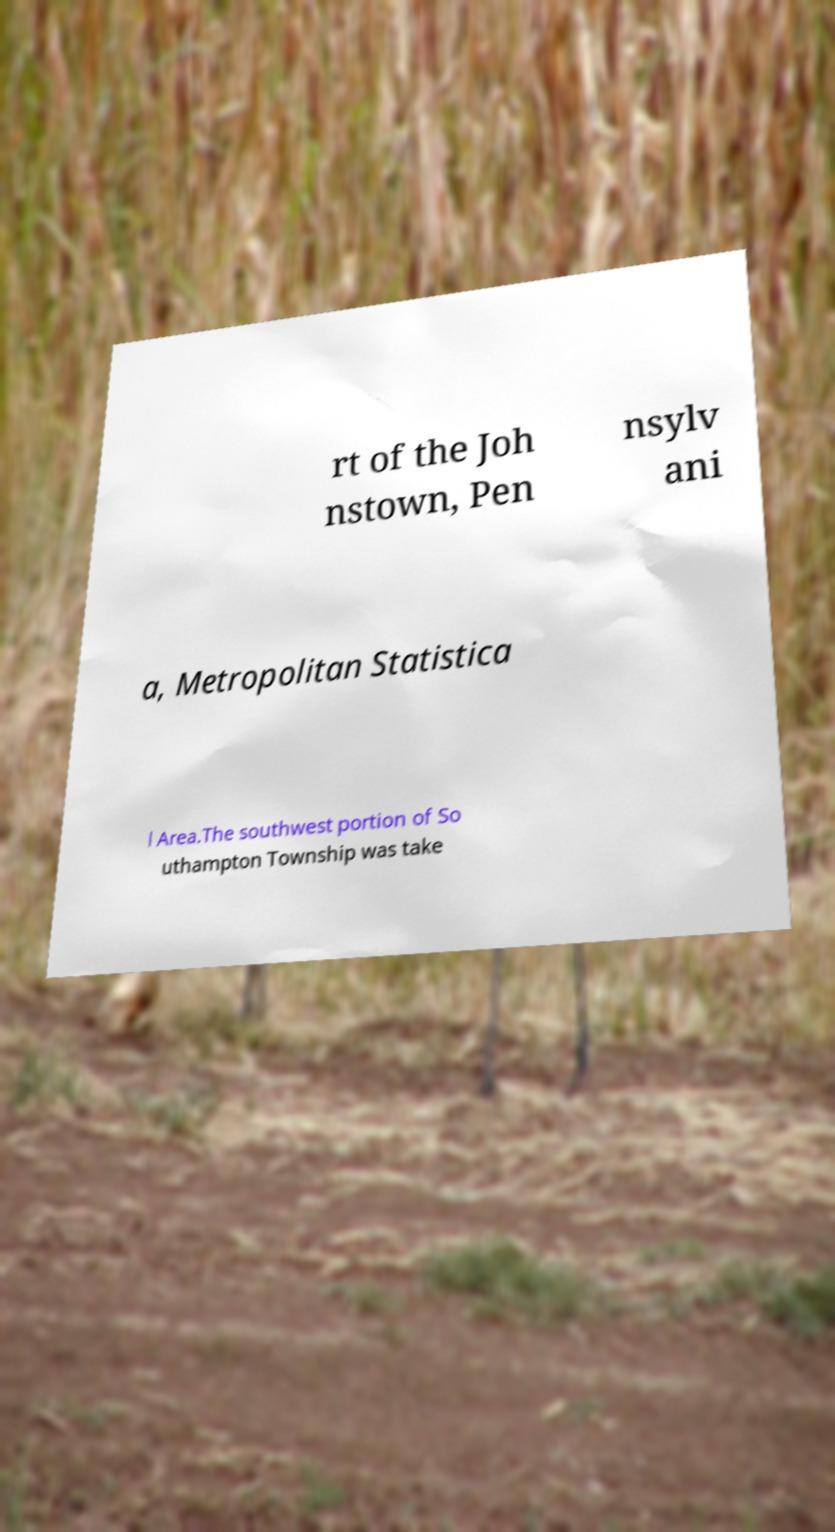Can you accurately transcribe the text from the provided image for me? rt of the Joh nstown, Pen nsylv ani a, Metropolitan Statistica l Area.The southwest portion of So uthampton Township was take 